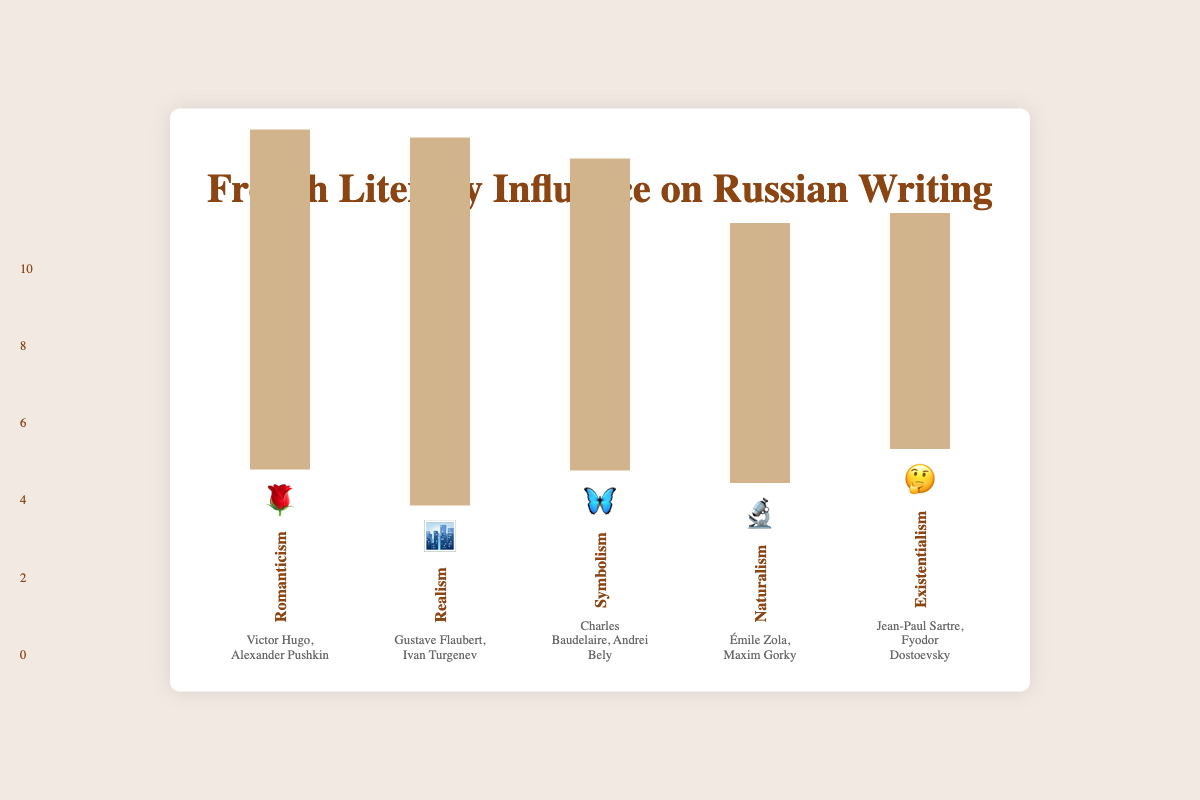What is the title of the figure? The title is located at the top center of the figure and states the overall theme or purpose of the chart. The text is "French Literary Influence on Russian Writing".
Answer: French Literary Influence on Russian Writing Which genre has the highest influence score? The tallest bar in the figure represents the genre with the highest influence score. The Realism genre, represented by an emoji 🏙️, has the tallest bar.
Answer: Realism How high is the bar for Symbolism in the figure? The height of the bar for each genre is proportional to its influence score. The Symbolism bar is at a height equal to an influence score of 7.8.
Answer: 7.8 Which genre has the lowest influence score? The shortest bar in the figure indicates the genre with the lowest influence score. The Existentialism genre, represented by an emoji 🤔, has the shortest bar.
Answer: Existentialism List the genres with their corresponding emojis. Each bar has an associated emoji further representing the genre. The genres and their emojis are: Romanticism 🌹, Realism 🏙️, Symbolism 🦋, Naturalism 🔬, and Existentialism 🤔.
Answer: 🌹, 🏙️, 🦋, 🔬, 🤔 What is the difference in influence score between Realism and Naturalism? Find the influence scores of Realism (9.2) and Naturalism (6.5), then subtract the smaller from the larger: 9.2 - 6.5 = 2.7.
Answer: 2.7 Which French and Russian authors are associated with Symbolism? Below each bar, associated key authors are listed for each genre. For Symbolism, the key authors are Charles Baudelaire and Andrei Bely.
Answer: Charles Baudelaire, Andrei Bely Arrange the genres in descending order of their influence scores. List the genres by height of their bars in descending order: Realism (9.2), Romanticism (8.5), Symbolism (7.8), Naturalism (6.5), Existentialism (5.9).
Answer: Realism, Romanticism, Symbolism, Naturalism, Existentialism Which genre's bar height is closest to 300px? Convert each influence score to its bar height. Romanticism (8.5) converts to 340px, Realism (9.2) to 368px, Symbolism (7.8) to 312px, Naturalism (6.5) to 260px, and Existentialism (5.9) to 236px. The Symbolism genre, with a score height of approximately 312px, is closest to 300px.
Answer: Symbolism Of the genres influenced by French literature, which has the lowest score but still over 6? Of the influence scores over 6, the lowest is 7.8, which corresponds to Symbolism.
Answer: Symbolism 